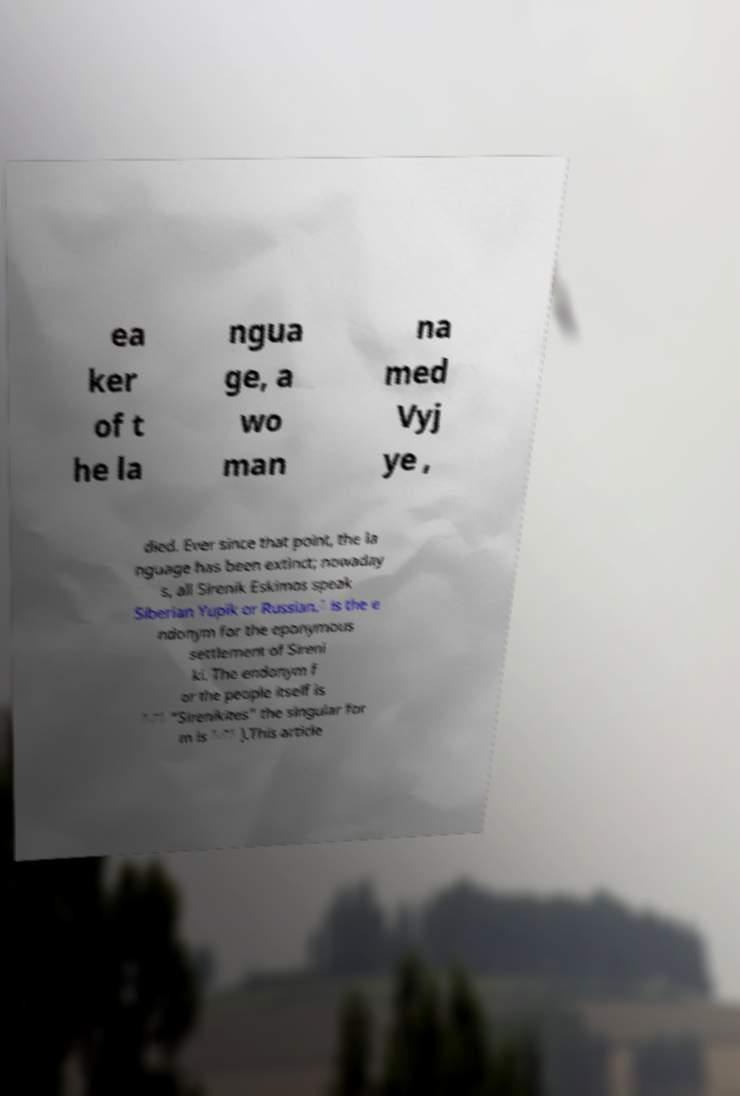There's text embedded in this image that I need extracted. Can you transcribe it verbatim? ea ker of t he la ngua ge, a wo man na med Vyj ye , died. Ever since that point, the la nguage has been extinct; nowaday s, all Sirenik Eskimos speak Siberian Yupik or Russian.́ is the e ndonym for the eponymous settlement of Sireni ki. The endonym f or the people itself is ́̄́ "Sirenikites" the singular for m is ́̄́ ).This article 